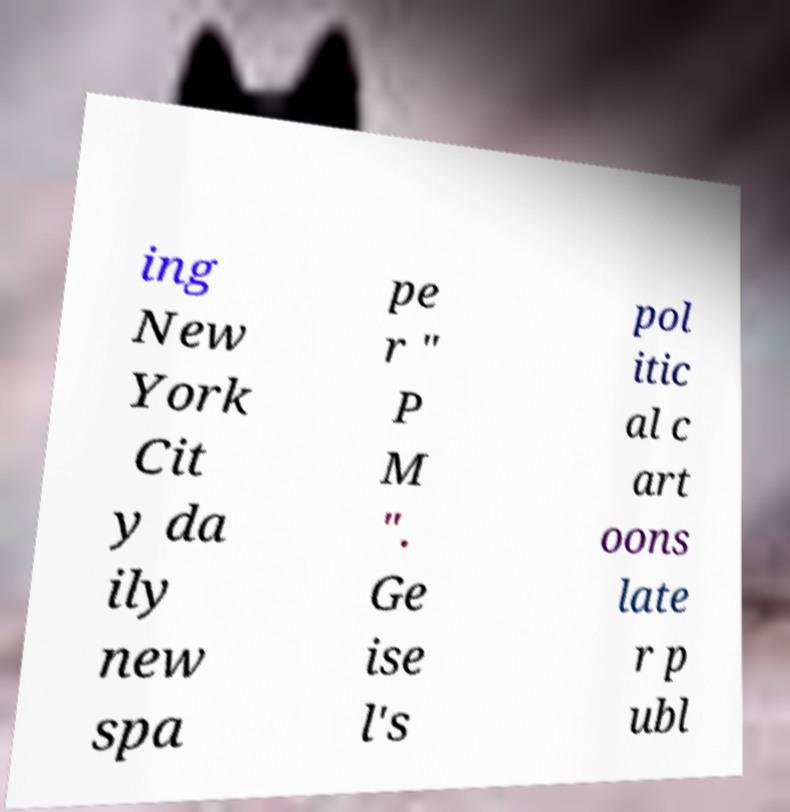Please identify and transcribe the text found in this image. ing New York Cit y da ily new spa pe r " P M ". Ge ise l's pol itic al c art oons late r p ubl 